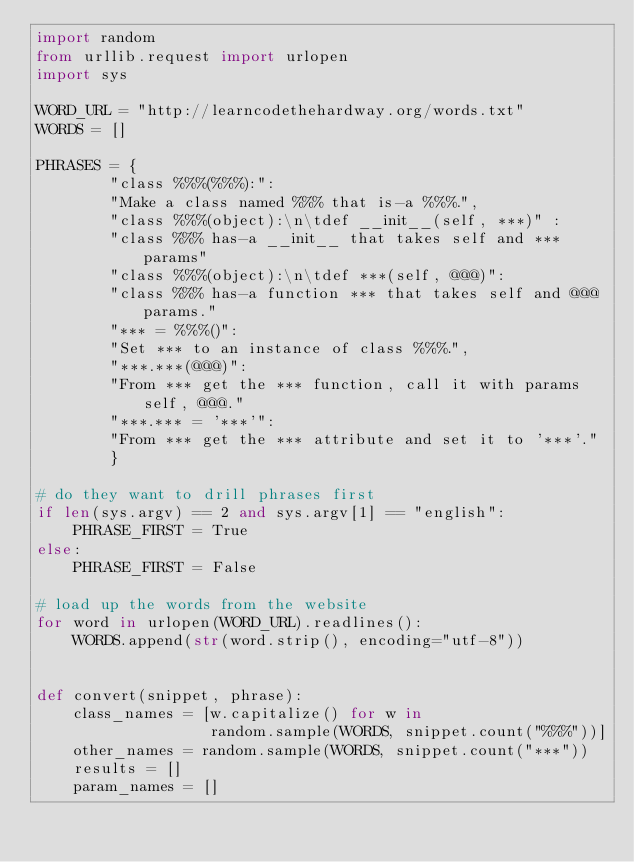<code> <loc_0><loc_0><loc_500><loc_500><_Python_>import random
from urllib.request import urlopen
import sys

WORD_URL = "http://learncodethehardway.org/words.txt"
WORDS = []

PHRASES = {
        "class %%%(%%%):":
        "Make a class named %%% that is-a %%%.",
        "class %%%(object):\n\tdef __init__(self, ***)" :
        "class %%% has-a __init__ that takes self and *** params"
        "class %%%(object):\n\tdef ***(self, @@@)":
        "class %%% has-a function *** that takes self and @@@ params."
        "*** = %%%()":
        "Set *** to an instance of class %%%.",
        "***.***(@@@)":
        "From *** get the *** function, call it with params self, @@@."
        "***.*** = '***'":
        "From *** get the *** attribute and set it to '***'."
        }

# do they want to drill phrases first
if len(sys.argv) == 2 and sys.argv[1] == "english":
    PHRASE_FIRST = True
else:
    PHRASE_FIRST = False

# load up the words from the website
for word in urlopen(WORD_URL).readlines():
    WORDS.append(str(word.strip(), encoding="utf-8"))


def convert(snippet, phrase):
    class_names = [w.capitalize() for w in
                   random.sample(WORDS, snippet.count("%%%"))]
    other_names = random.sample(WORDS, snippet.count("***"))
    results = []
    param_names = []
</code> 